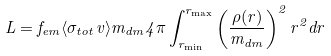<formula> <loc_0><loc_0><loc_500><loc_500>L = f _ { e m } \langle \sigma _ { t o t } v \rangle m _ { d m } 4 \pi \int _ { r _ { \min } } ^ { r _ { \max } } \left ( \frac { \rho ( r ) } { m _ { d m } } \right ) ^ { 2 } r ^ { 2 } d r</formula> 